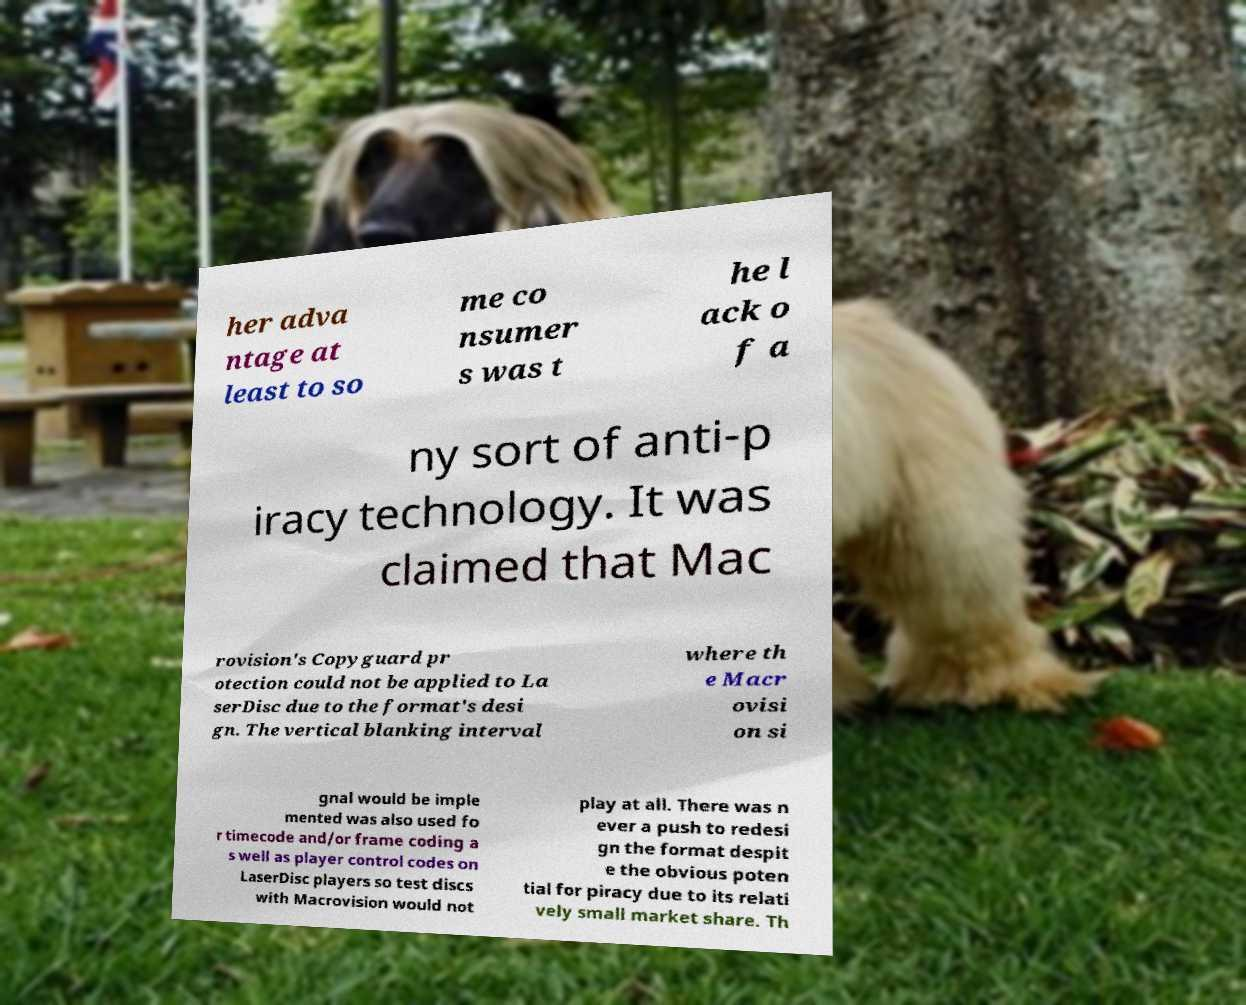Could you extract and type out the text from this image? her adva ntage at least to so me co nsumer s was t he l ack o f a ny sort of anti-p iracy technology. It was claimed that Mac rovision's Copyguard pr otection could not be applied to La serDisc due to the format's desi gn. The vertical blanking interval where th e Macr ovisi on si gnal would be imple mented was also used fo r timecode and/or frame coding a s well as player control codes on LaserDisc players so test discs with Macrovision would not play at all. There was n ever a push to redesi gn the format despit e the obvious poten tial for piracy due to its relati vely small market share. Th 